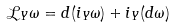Convert formula to latex. <formula><loc_0><loc_0><loc_500><loc_500>\mathcal { L } _ { Y } \omega = d ( i _ { Y } \omega ) + i _ { Y } ( d \omega )</formula> 